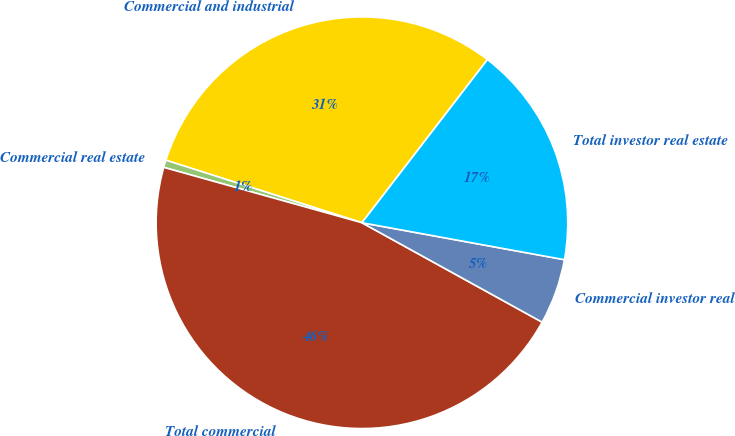Convert chart to OTSL. <chart><loc_0><loc_0><loc_500><loc_500><pie_chart><fcel>Commercial and industrial<fcel>Commercial real estate<fcel>Total commercial<fcel>Commercial investor real<fcel>Total investor real estate<nl><fcel>30.52%<fcel>0.58%<fcel>46.31%<fcel>5.15%<fcel>17.44%<nl></chart> 